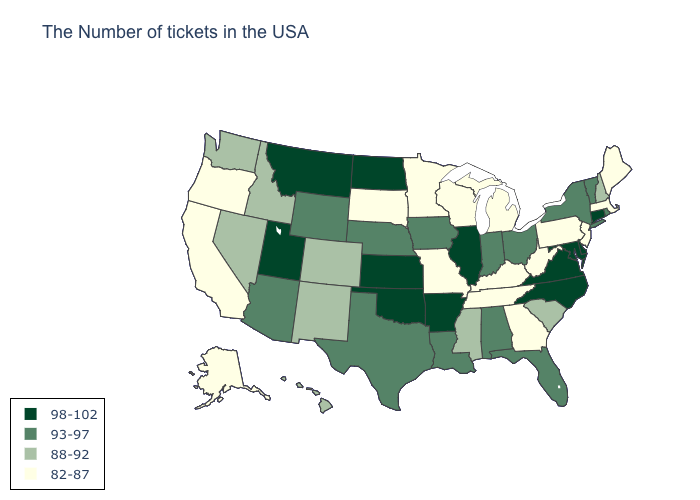What is the lowest value in the USA?
Be succinct. 82-87. Name the states that have a value in the range 82-87?
Quick response, please. Maine, Massachusetts, New Jersey, Pennsylvania, West Virginia, Georgia, Michigan, Kentucky, Tennessee, Wisconsin, Missouri, Minnesota, South Dakota, California, Oregon, Alaska. Is the legend a continuous bar?
Quick response, please. No. Does Alabama have the highest value in the USA?
Concise answer only. No. Does Maine have the lowest value in the USA?
Give a very brief answer. Yes. What is the lowest value in the MidWest?
Quick response, please. 82-87. Does the first symbol in the legend represent the smallest category?
Write a very short answer. No. What is the value of Maine?
Keep it brief. 82-87. What is the lowest value in the USA?
Answer briefly. 82-87. What is the value of Maryland?
Short answer required. 98-102. How many symbols are there in the legend?
Keep it brief. 4. What is the value of Rhode Island?
Give a very brief answer. 93-97. Does Connecticut have the highest value in the Northeast?
Concise answer only. Yes. Among the states that border Wyoming , does Utah have the highest value?
Short answer required. Yes. 